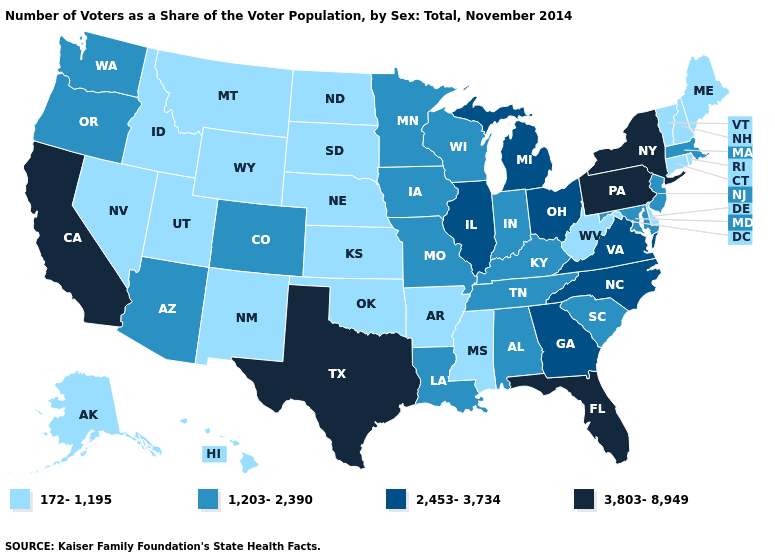What is the highest value in states that border Tennessee?
Quick response, please. 2,453-3,734. Which states have the lowest value in the USA?
Be succinct. Alaska, Arkansas, Connecticut, Delaware, Hawaii, Idaho, Kansas, Maine, Mississippi, Montana, Nebraska, Nevada, New Hampshire, New Mexico, North Dakota, Oklahoma, Rhode Island, South Dakota, Utah, Vermont, West Virginia, Wyoming. Name the states that have a value in the range 3,803-8,949?
Concise answer only. California, Florida, New York, Pennsylvania, Texas. What is the highest value in the USA?
Give a very brief answer. 3,803-8,949. Which states have the highest value in the USA?
Answer briefly. California, Florida, New York, Pennsylvania, Texas. How many symbols are there in the legend?
Give a very brief answer. 4. Among the states that border Connecticut , which have the lowest value?
Quick response, please. Rhode Island. What is the highest value in the USA?
Short answer required. 3,803-8,949. Does the first symbol in the legend represent the smallest category?
Answer briefly. Yes. What is the lowest value in the USA?
Concise answer only. 172-1,195. Which states hav the highest value in the South?
Keep it brief. Florida, Texas. Which states hav the highest value in the MidWest?
Be succinct. Illinois, Michigan, Ohio. What is the value of Alabama?
Write a very short answer. 1,203-2,390. What is the value of Massachusetts?
Concise answer only. 1,203-2,390. What is the highest value in the USA?
Short answer required. 3,803-8,949. 